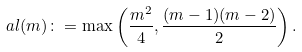<formula> <loc_0><loc_0><loc_500><loc_500>\ a l ( m ) \colon = \max \left ( \frac { m ^ { 2 } } 4 , \frac { ( m - 1 ) ( m - 2 ) } 2 \right ) .</formula> 